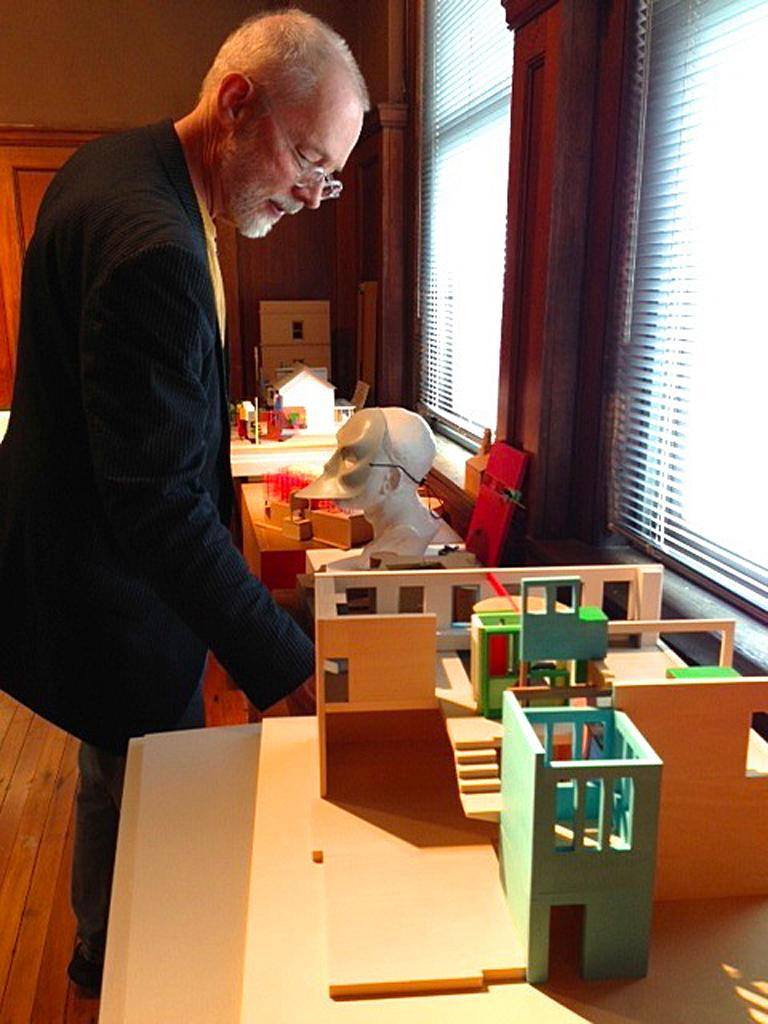What is the main subject of the image? The main subject of the image is a man. What is the man doing in the image? The man is standing in the image. What object can be seen in the image besides the man? There is a table in the image. What type of pen is the man holding in the image? There is no pen present in the image. What kind of toy can be seen on the table in the image? There is no toy present on the table in the image. 